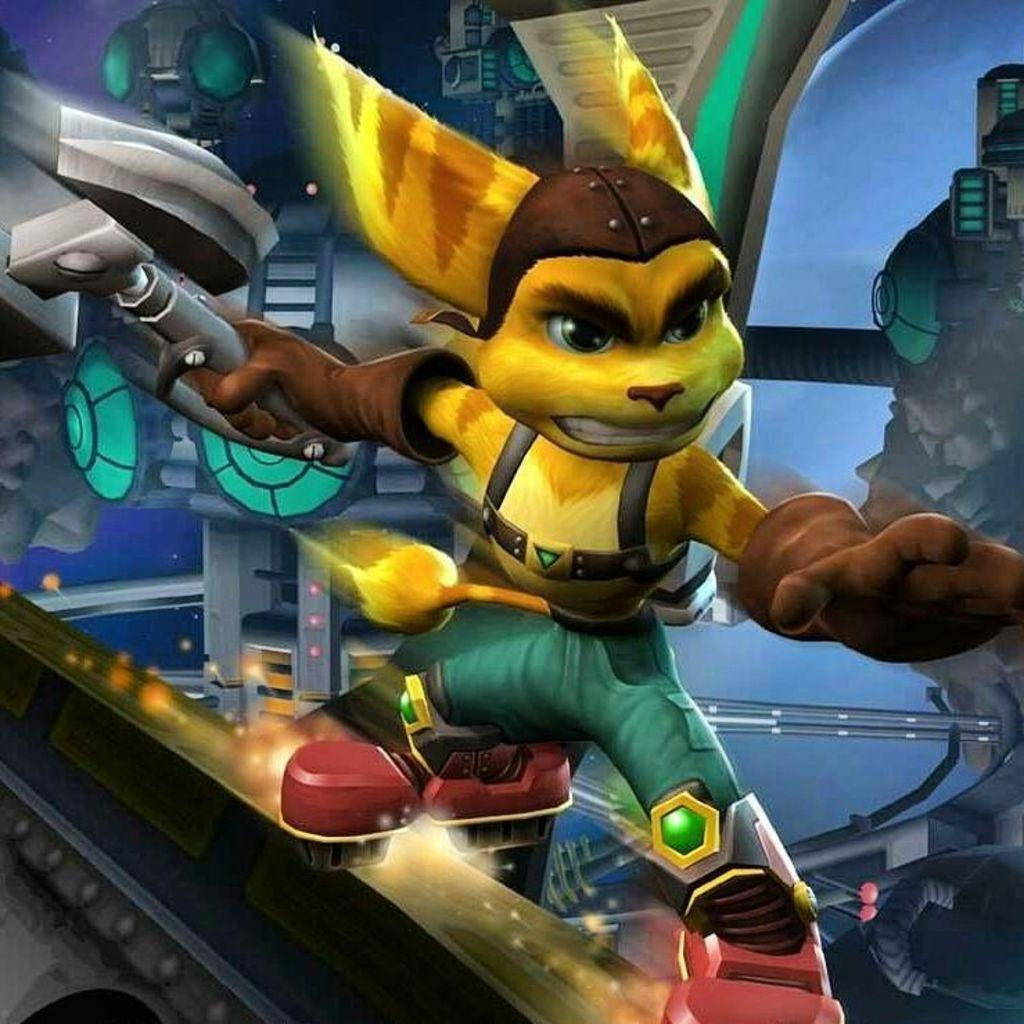What type of image is present in the picture? There is an animated image in the picture. What is the animated image doing? The animated image is holding a weapon. What type of song is the animated image singing in the image? There is no indication in the image that the animated image is singing a song. 